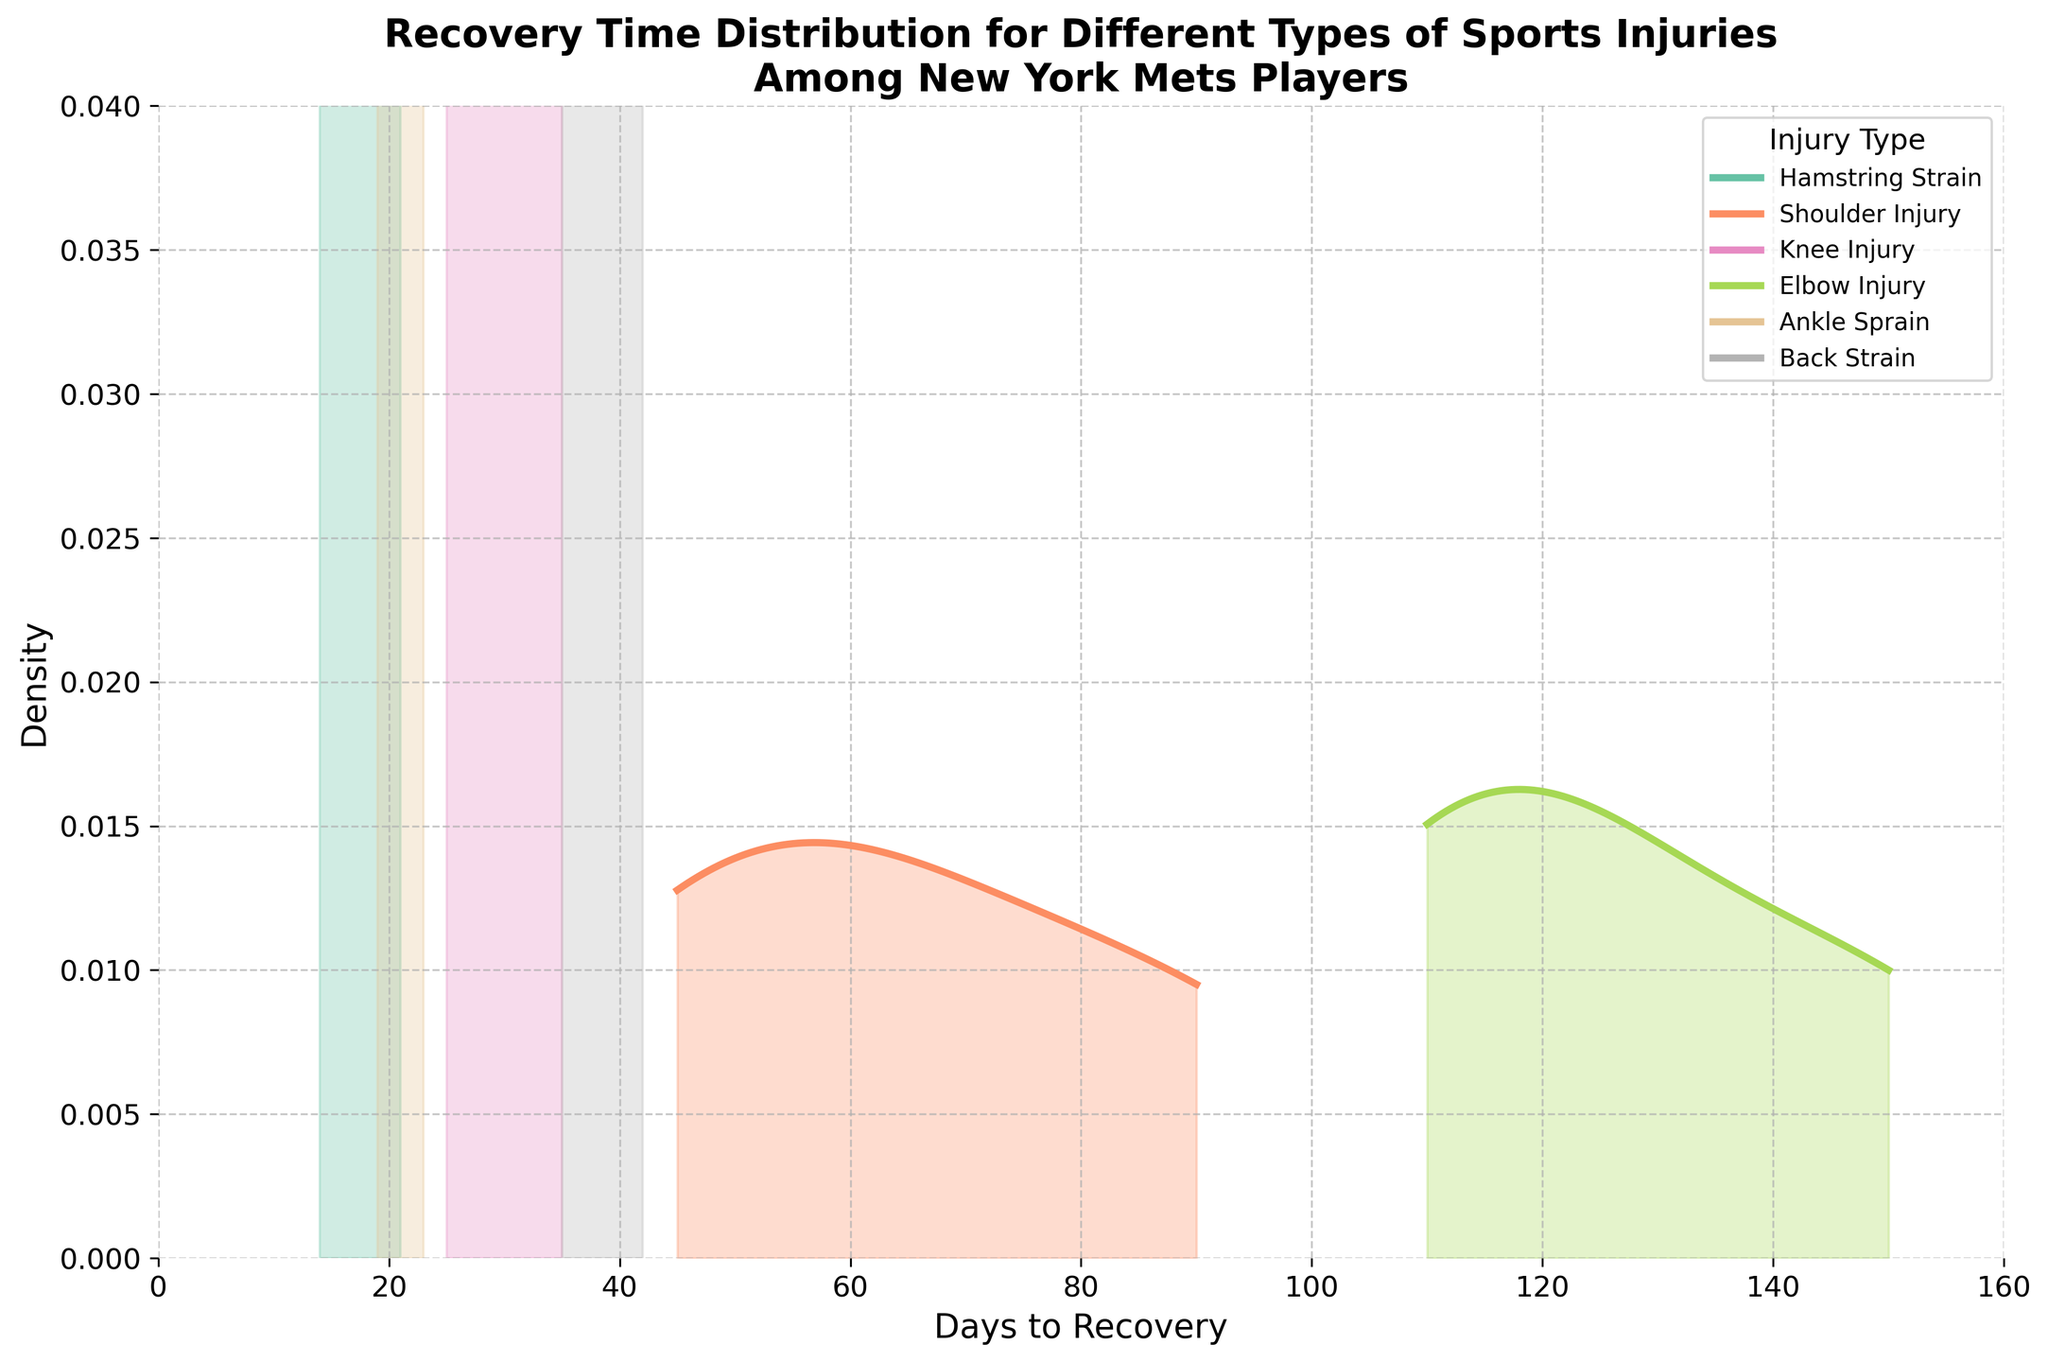What is the title of the plot? The title of the plot is prominently displayed at the top of the figure. Title is usually bold and bigger in size compared to other text. By reading the text at the top of the figure, you can determine the title.
Answer: Recovery Time Distribution for Different Types of Sports Injuries Among New York Mets Players What is the x-axis label? The x-axis label is typically found along the horizontal axis at the bottom of the plot. It provides context for what the x-axis represents.
Answer: Days to Recovery What is the range of the x-axis? The range of the x-axis can be determined by examining the minimum and maximum values displayed along the horizontal axis.
Answer: 0 to 160 days Which injury type has the longest recovery time? To determine the injury type with the longest recovery time, observe the maximum value on the x-axis and see which injury type's density extends the furthest to the right.
Answer: Elbow Injury Which density distribution appears to have the highest peak? By comparing the heights of the peaks in the density distributions, you can identify which one reaches the highest point.
Answer: Hamstring Strain Which injury type has the broadest spread of recovery times? The injury type with the broadest spread will have the widest range on the x-axis, observable by the extent of the density plot.
Answer: Elbow Injury What is the approximate peak density value for Shoulder Injuries? Examine the height of the peak of the density plot for Shoulder Injuries on the y-axis to approximate its highest value.
Answer: Approximately 0.008 How does the peak of Back Strain compare to the peak of Ankle Sprain? Compare the heights of the peak points of the density plots for Back Strain and Ankle Sprain. Identify which one is higher and by how much.
Answer: The peak of Back Strain is slightly higher than Ankle Sprain What is the peak density value for Hamstring Strain and Ankle Sprain? Identify the highest point on each density plot by following the y-axis values.
Answer: Hamstring Strain: approximately 0.03, Ankle Sprain: approximately 0.02 How are Shoulder Injuries and Knee Injuries different in terms of their recovery times distribution? Compare the density plots for Shoulder and Knee Injuries. Shoulder Injuries tend to have a longer recovery time and a more spread-out distribution than Knee Injuries have. This can be determined by looking at the range and shape of the density plots.
Answer: Shoulder Injuries have longer and more spread-out recovery times 